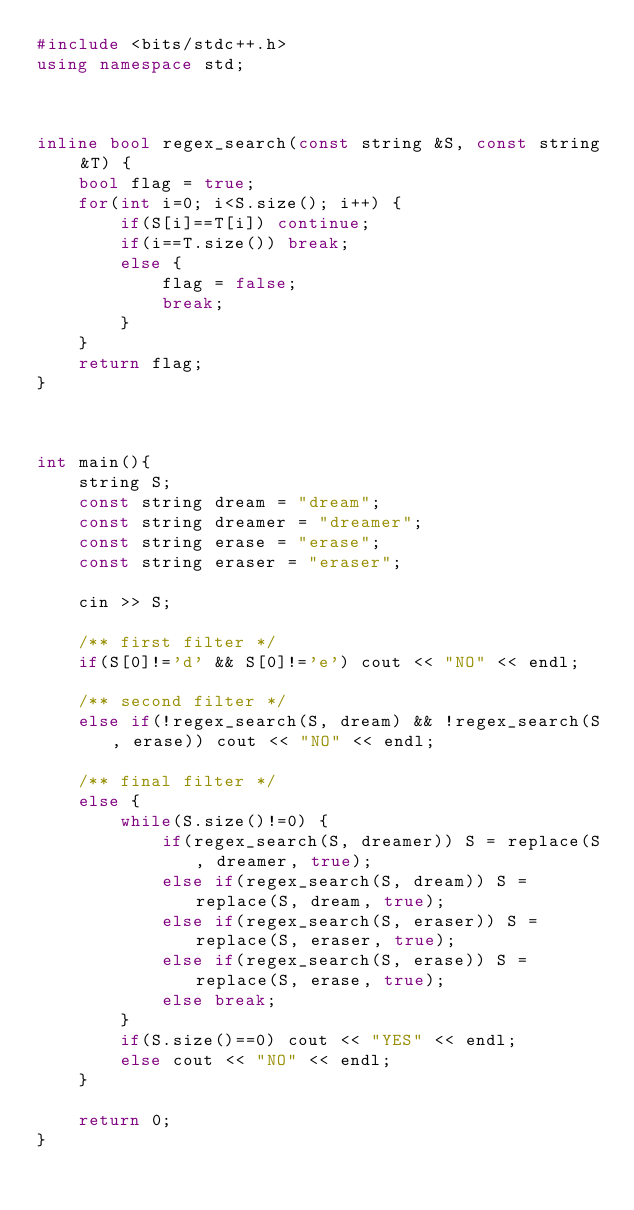<code> <loc_0><loc_0><loc_500><loc_500><_C++_>#include <bits/stdc++.h>
using namespace std;
 
 
 
inline bool regex_search(const string &S, const string &T) {
    bool flag = true;  
    for(int i=0; i<S.size(); i++) {
        if(S[i]==T[i]) continue;
        if(i==T.size()) break;
        else {
            flag = false;
            break;
        }
    }
    return flag;
}
 
 
 
int main(){
    string S;
    const string dream = "dream";
    const string dreamer = "dreamer";
    const string erase = "erase";
    const string eraser = "eraser";
 
    cin >> S;
 
    /** first filter */
    if(S[0]!='d' && S[0]!='e') cout << "NO" << endl;
    
    /** second filter */
    else if(!regex_search(S, dream) && !regex_search(S, erase)) cout << "NO" << endl;
 
    /** final filter */
    else {
        while(S.size()!=0) {
            if(regex_search(S, dreamer)) S = replace(S, dreamer, true);
            else if(regex_search(S, dream)) S = replace(S, dream, true);
            else if(regex_search(S, eraser)) S = replace(S, eraser, true);
            else if(regex_search(S, erase)) S = replace(S, erase, true);
            else break;
        }
        if(S.size()==0) cout << "YES" << endl;
        else cout << "NO" << endl;
    }
 
    return 0;
}</code> 